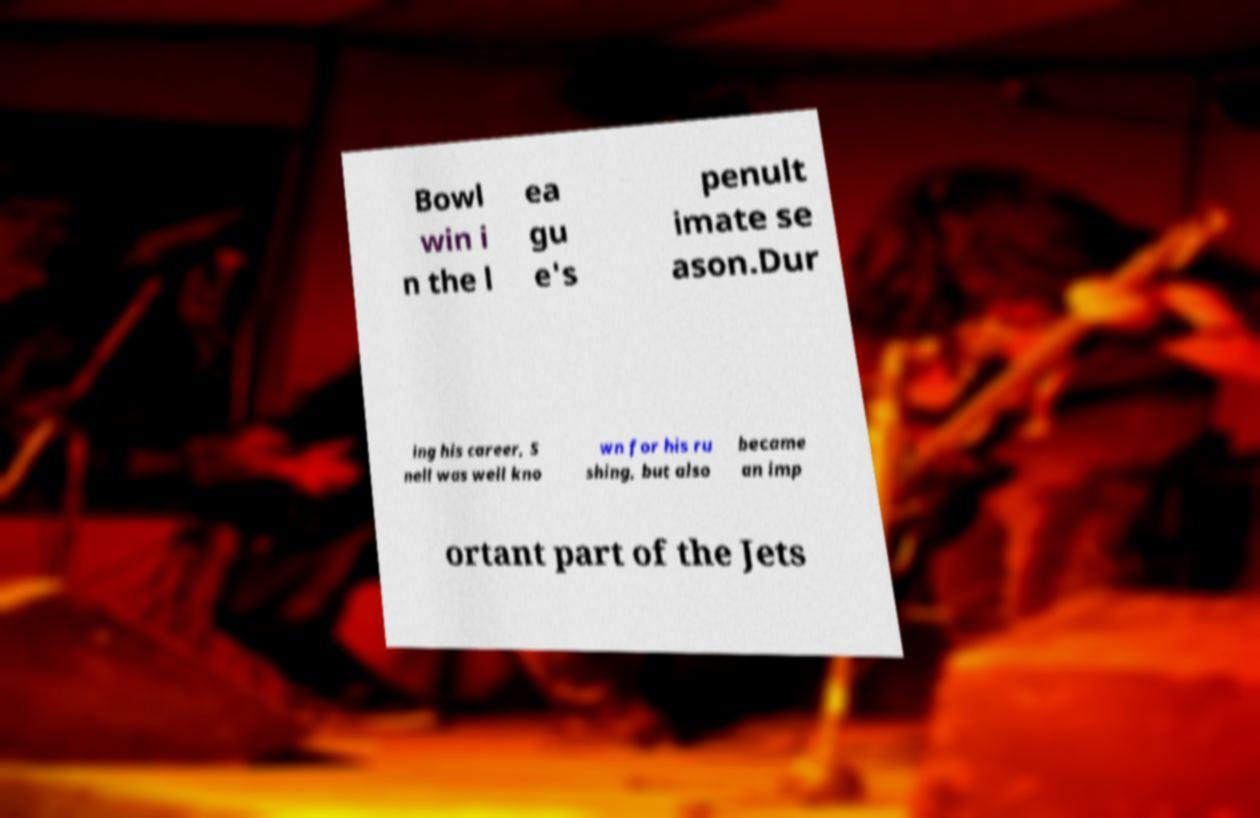What messages or text are displayed in this image? I need them in a readable, typed format. Bowl win i n the l ea gu e's penult imate se ason.Dur ing his career, S nell was well kno wn for his ru shing, but also became an imp ortant part of the Jets 